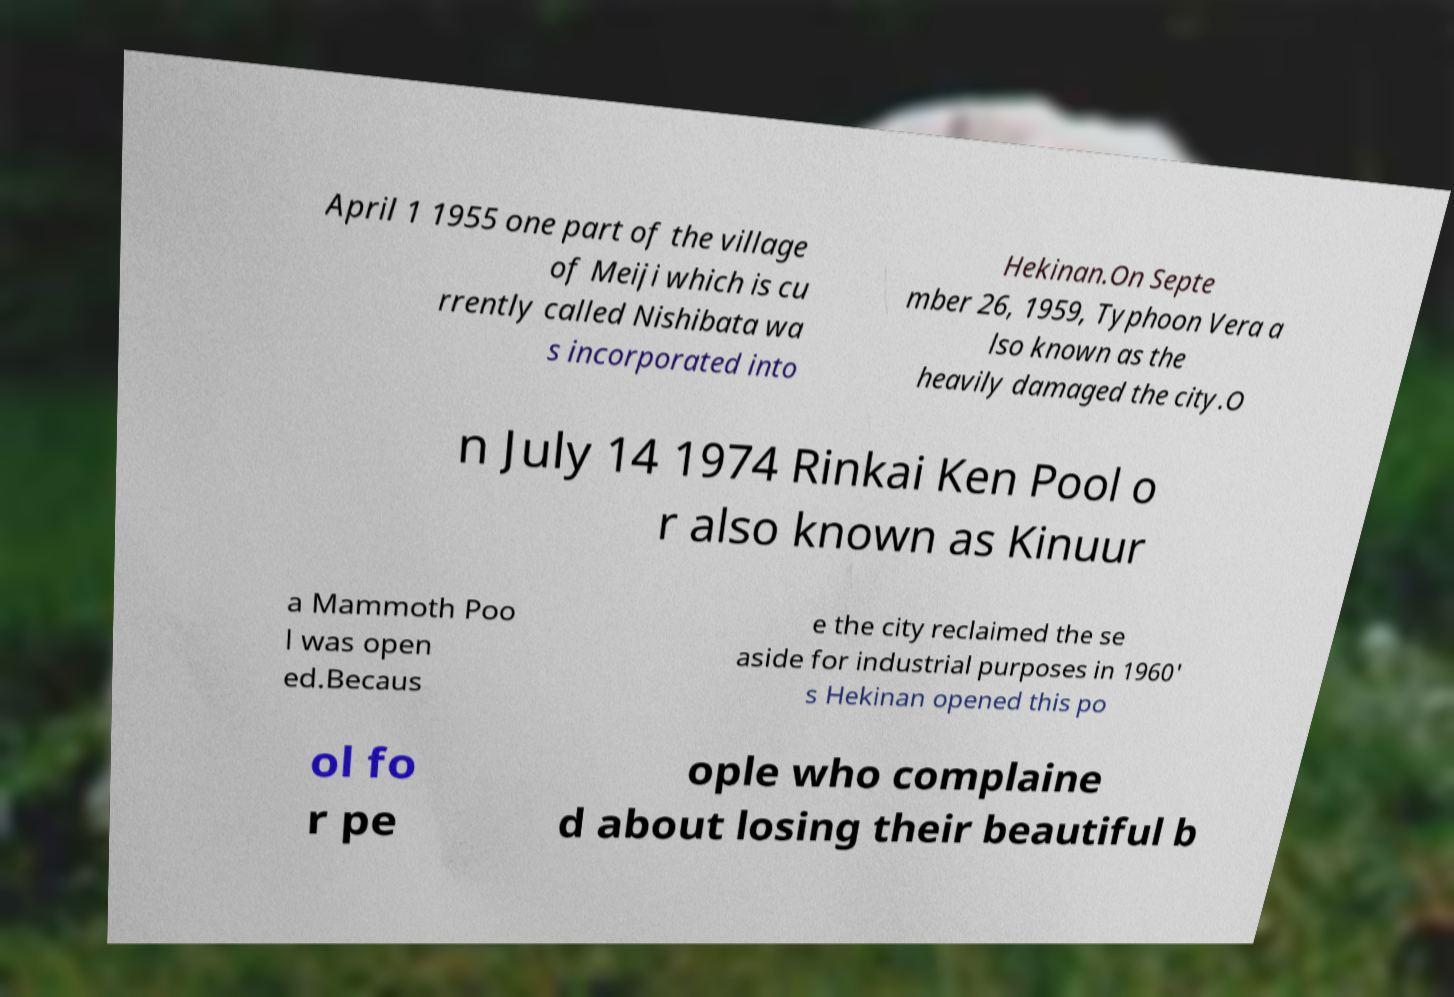Can you read and provide the text displayed in the image?This photo seems to have some interesting text. Can you extract and type it out for me? April 1 1955 one part of the village of Meiji which is cu rrently called Nishibata wa s incorporated into Hekinan.On Septe mber 26, 1959, Typhoon Vera a lso known as the heavily damaged the city.O n July 14 1974 Rinkai Ken Pool o r also known as Kinuur a Mammoth Poo l was open ed.Becaus e the city reclaimed the se aside for industrial purposes in 1960' s Hekinan opened this po ol fo r pe ople who complaine d about losing their beautiful b 